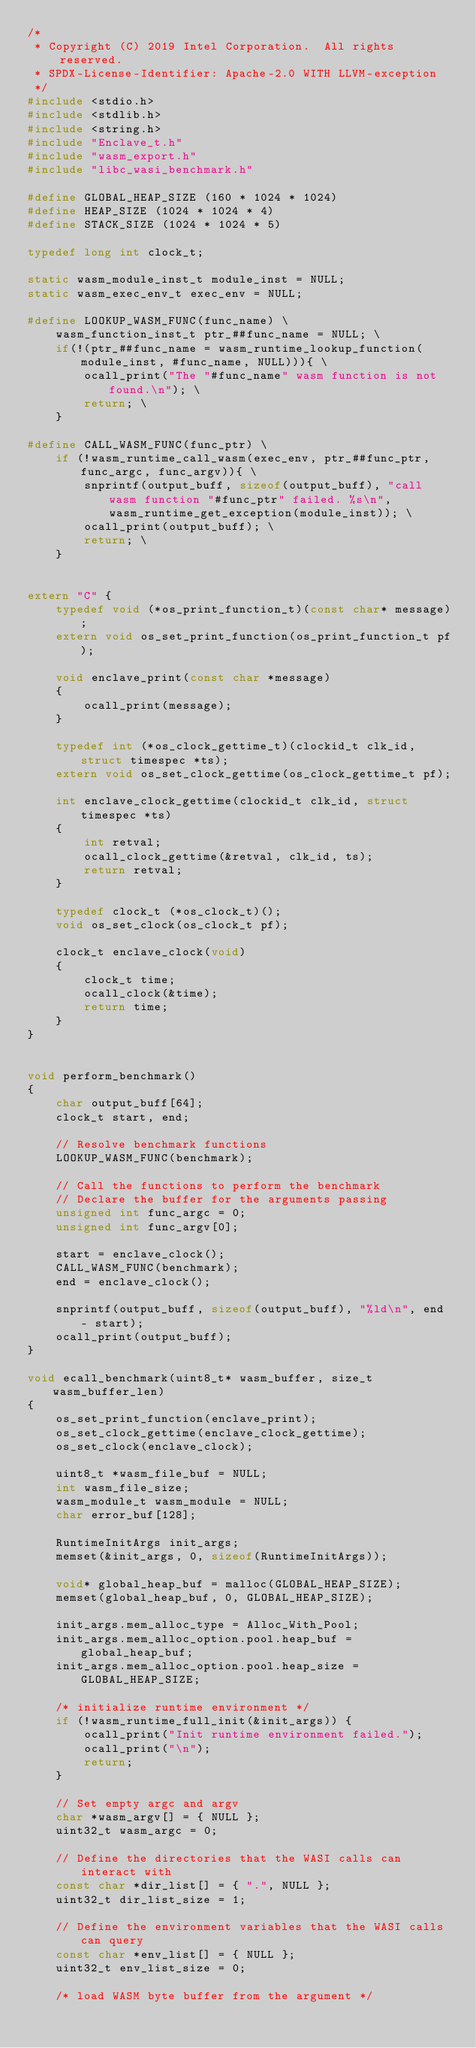Convert code to text. <code><loc_0><loc_0><loc_500><loc_500><_C++_>/*
 * Copyright (C) 2019 Intel Corporation.  All rights reserved.
 * SPDX-License-Identifier: Apache-2.0 WITH LLVM-exception
 */
#include <stdio.h>
#include <stdlib.h>
#include <string.h>
#include "Enclave_t.h"
#include "wasm_export.h"
#include "libc_wasi_benchmark.h"

#define GLOBAL_HEAP_SIZE (160 * 1024 * 1024)
#define HEAP_SIZE (1024 * 1024 * 4)
#define STACK_SIZE (1024 * 1024 * 5)

typedef long int clock_t;

static wasm_module_inst_t module_inst = NULL;
static wasm_exec_env_t exec_env = NULL;

#define LOOKUP_WASM_FUNC(func_name) \
    wasm_function_inst_t ptr_##func_name = NULL; \
    if(!(ptr_##func_name = wasm_runtime_lookup_function(module_inst, #func_name, NULL))){ \
        ocall_print("The "#func_name" wasm function is not found.\n"); \
        return; \
    }

#define CALL_WASM_FUNC(func_ptr) \
    if (!wasm_runtime_call_wasm(exec_env, ptr_##func_ptr, func_argc, func_argv)){ \
        snprintf(output_buff, sizeof(output_buff), "call wasm function "#func_ptr" failed. %s\n", wasm_runtime_get_exception(module_inst)); \
        ocall_print(output_buff); \
        return; \
    } 


extern "C" {
    typedef void (*os_print_function_t)(const char* message);
    extern void os_set_print_function(os_print_function_t pf);

    void enclave_print(const char *message)
    {
        ocall_print(message);
    }
    
    typedef int (*os_clock_gettime_t)(clockid_t clk_id, struct timespec *ts);
    extern void os_set_clock_gettime(os_clock_gettime_t pf);

    int enclave_clock_gettime(clockid_t clk_id, struct timespec *ts)
    {
        int retval;
        ocall_clock_gettime(&retval, clk_id, ts);
        return retval;
    }

    typedef clock_t (*os_clock_t)();
    void os_set_clock(os_clock_t pf);

    clock_t enclave_clock(void)
    {
        clock_t time;
        ocall_clock(&time);
        return time;
    }
}


void perform_benchmark()
{
    char output_buff[64];
    clock_t start, end;

    // Resolve benchmark functions
    LOOKUP_WASM_FUNC(benchmark);

    // Call the functions to perform the benchmark
    // Declare the buffer for the arguments passing
    unsigned int func_argc = 0;
    unsigned int func_argv[0];

    start = enclave_clock();
    CALL_WASM_FUNC(benchmark);
    end = enclave_clock();

    snprintf(output_buff, sizeof(output_buff), "%ld\n", end - start);
    ocall_print(output_buff);
}

void ecall_benchmark(uint8_t* wasm_buffer, size_t wasm_buffer_len)
{
    os_set_print_function(enclave_print);
    os_set_clock_gettime(enclave_clock_gettime);
    os_set_clock(enclave_clock);
    
    uint8_t *wasm_file_buf = NULL;
    int wasm_file_size;
    wasm_module_t wasm_module = NULL;
    char error_buf[128];

    RuntimeInitArgs init_args;
    memset(&init_args, 0, sizeof(RuntimeInitArgs));

    void* global_heap_buf = malloc(GLOBAL_HEAP_SIZE);
    memset(global_heap_buf, 0, GLOBAL_HEAP_SIZE);

    init_args.mem_alloc_type = Alloc_With_Pool;
    init_args.mem_alloc_option.pool.heap_buf = global_heap_buf;
    init_args.mem_alloc_option.pool.heap_size = GLOBAL_HEAP_SIZE;

    /* initialize runtime environment */
    if (!wasm_runtime_full_init(&init_args)) {
        ocall_print("Init runtime environment failed.");
        ocall_print("\n");
        return;
    }

    // Set empty argc and argv
    char *wasm_argv[] = { NULL };
    uint32_t wasm_argc = 0;

    // Define the directories that the WASI calls can interact with
    const char *dir_list[] = { ".", NULL };
    uint32_t dir_list_size = 1;

    // Define the environment variables that the WASI calls can query
    const char *env_list[] = { NULL };
    uint32_t env_list_size = 0;

    /* load WASM byte buffer from the argument */</code> 